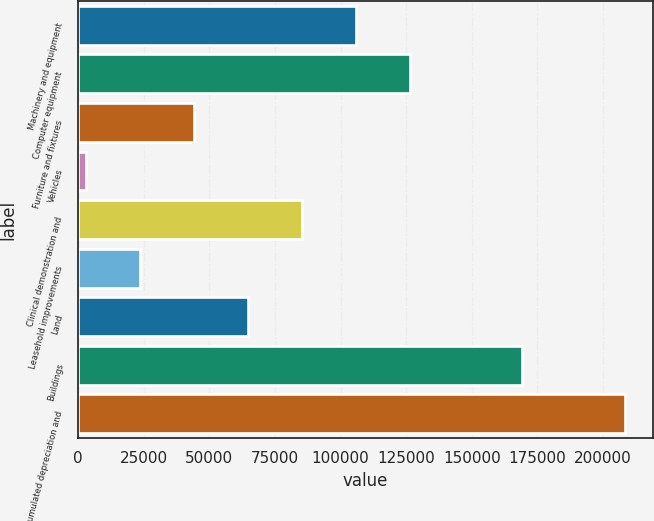Convert chart to OTSL. <chart><loc_0><loc_0><loc_500><loc_500><bar_chart><fcel>Machinery and equipment<fcel>Computer equipment<fcel>Furniture and fixtures<fcel>Vehicles<fcel>Clinical demonstration and<fcel>Leasehold improvements<fcel>Land<fcel>Buildings<fcel>Accumulated depreciation and<nl><fcel>105772<fcel>126307<fcel>44168.4<fcel>3099<fcel>85237.8<fcel>23633.7<fcel>64703.1<fcel>169076<fcel>208446<nl></chart> 